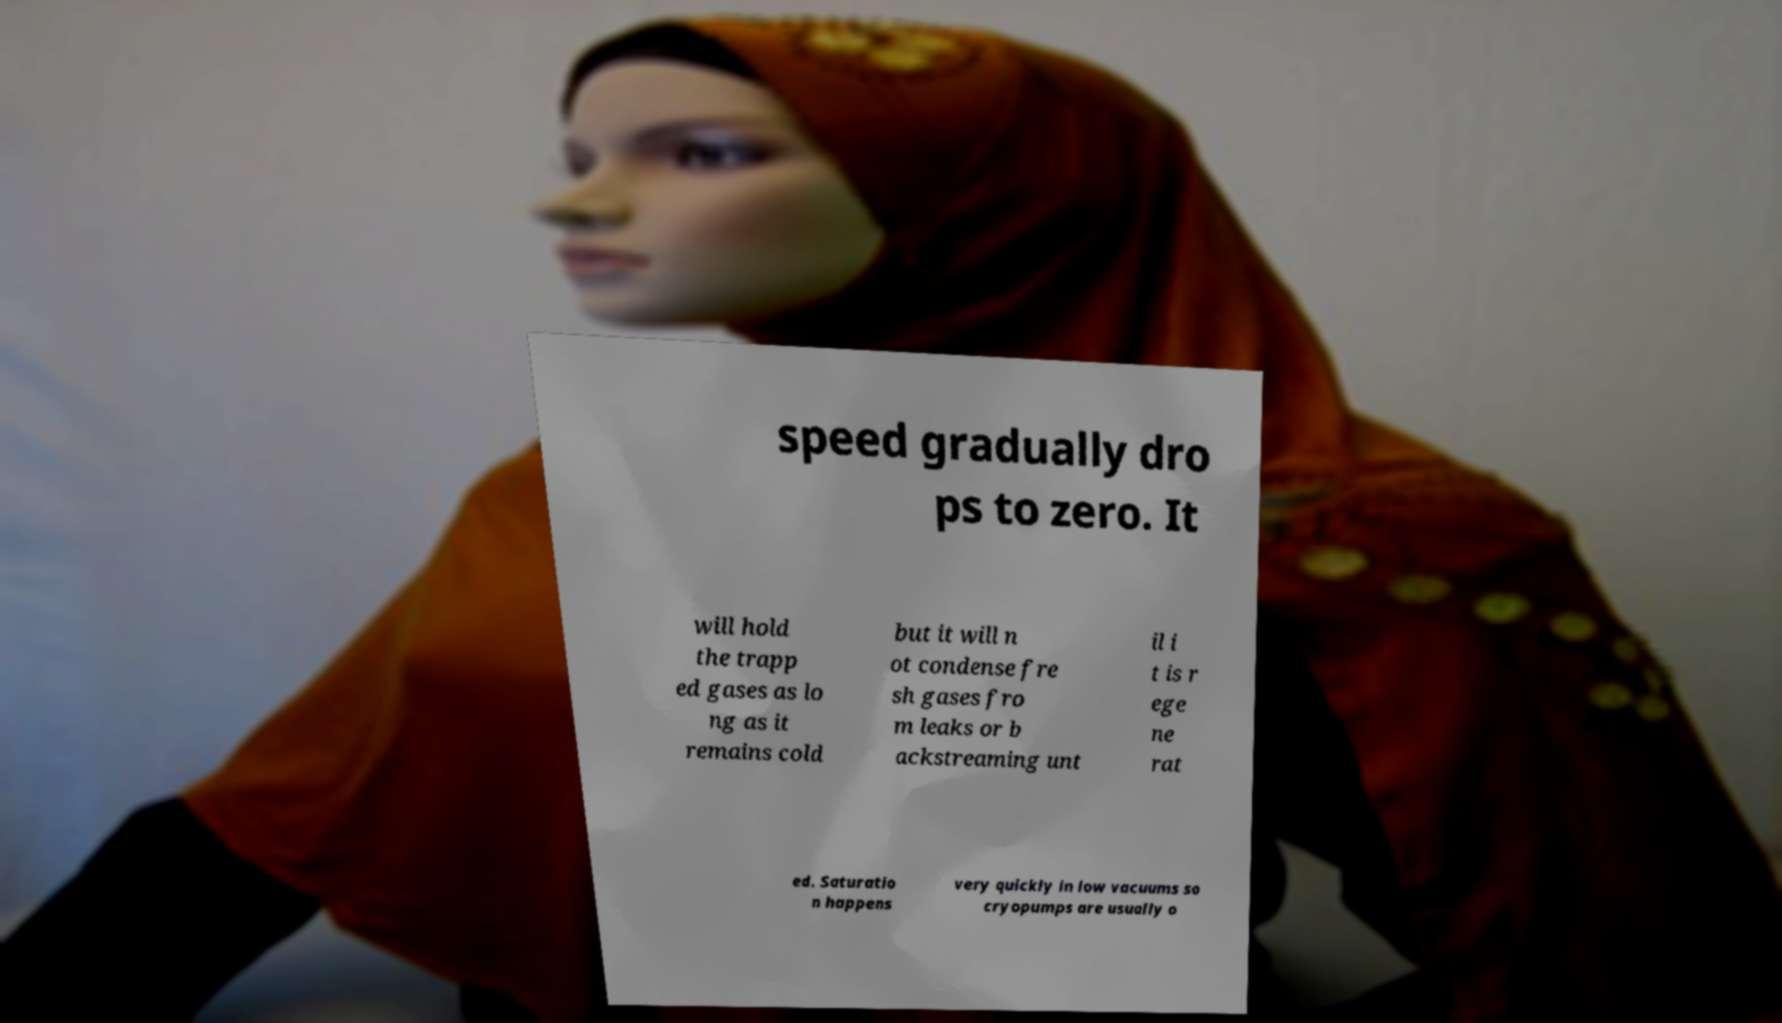Can you read and provide the text displayed in the image?This photo seems to have some interesting text. Can you extract and type it out for me? speed gradually dro ps to zero. It will hold the trapp ed gases as lo ng as it remains cold but it will n ot condense fre sh gases fro m leaks or b ackstreaming unt il i t is r ege ne rat ed. Saturatio n happens very quickly in low vacuums so cryopumps are usually o 